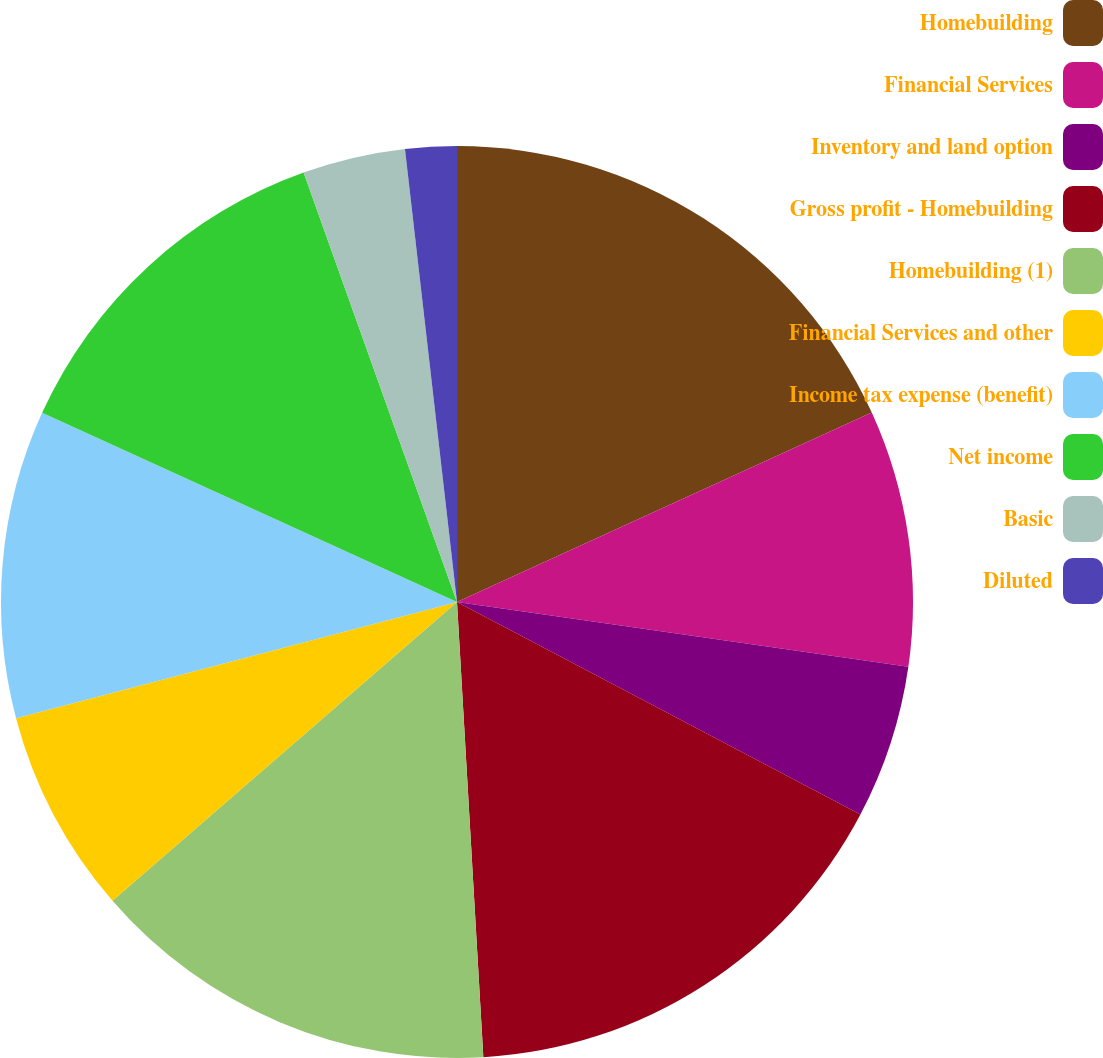Convert chart to OTSL. <chart><loc_0><loc_0><loc_500><loc_500><pie_chart><fcel>Homebuilding<fcel>Financial Services<fcel>Inventory and land option<fcel>Gross profit - Homebuilding<fcel>Homebuilding (1)<fcel>Financial Services and other<fcel>Income tax expense (benefit)<fcel>Net income<fcel>Basic<fcel>Diluted<nl><fcel>18.18%<fcel>9.09%<fcel>5.45%<fcel>16.36%<fcel>14.55%<fcel>7.27%<fcel>10.91%<fcel>12.73%<fcel>3.64%<fcel>1.82%<nl></chart> 